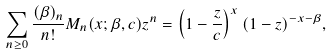<formula> <loc_0><loc_0><loc_500><loc_500>\sum _ { n \geq 0 } \frac { ( \beta ) _ { n } } { n ! } M _ { n } ( x ; \beta , c ) z ^ { n } = \left ( 1 - \frac { z } { c } \right ) ^ { x } ( 1 - z ) ^ { - x - \beta } ,</formula> 